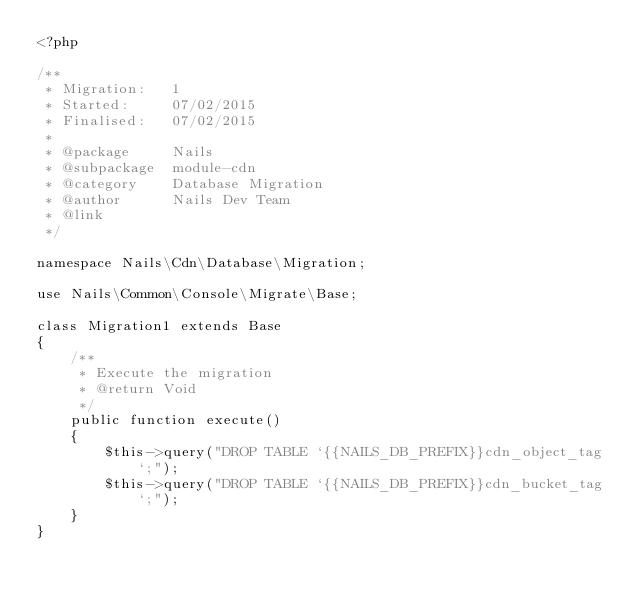Convert code to text. <code><loc_0><loc_0><loc_500><loc_500><_PHP_><?php

/**
 * Migration:   1
 * Started:     07/02/2015
 * Finalised:   07/02/2015
 *
 * @package     Nails
 * @subpackage  module-cdn
 * @category    Database Migration
 * @author      Nails Dev Team
 * @link
 */

namespace Nails\Cdn\Database\Migration;

use Nails\Common\Console\Migrate\Base;

class Migration1 extends Base
{
    /**
     * Execute the migration
     * @return Void
     */
    public function execute()
    {
        $this->query("DROP TABLE `{{NAILS_DB_PREFIX}}cdn_object_tag`;");
        $this->query("DROP TABLE `{{NAILS_DB_PREFIX}}cdn_bucket_tag`;");
    }
}
</code> 